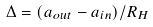Convert formula to latex. <formula><loc_0><loc_0><loc_500><loc_500>\Delta = ( a _ { o u t } - a _ { i n } ) / R _ { H }</formula> 